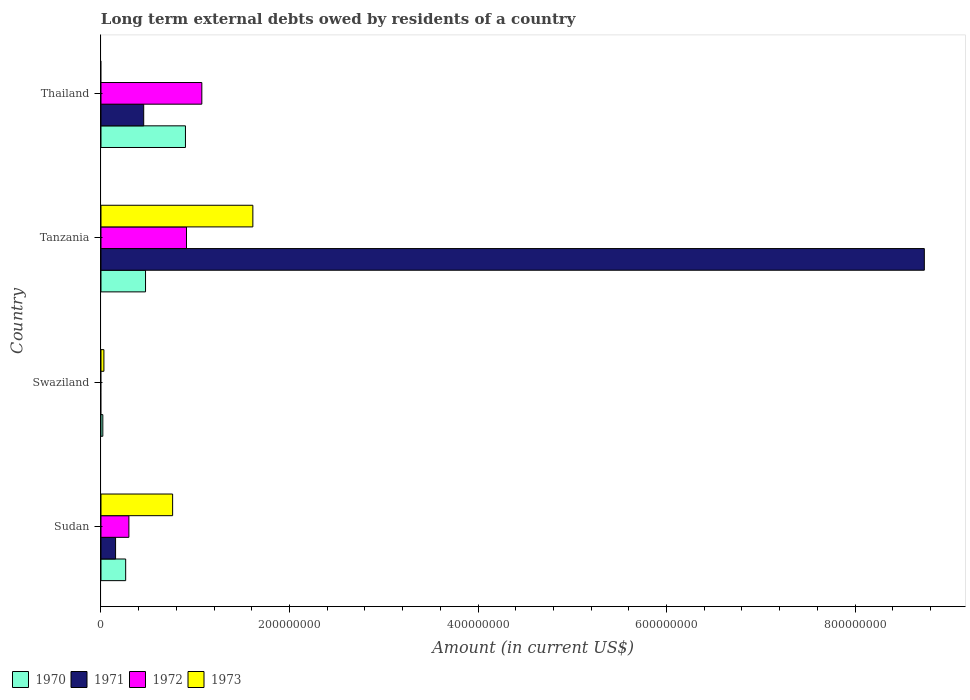How many different coloured bars are there?
Make the answer very short. 4. What is the label of the 4th group of bars from the top?
Offer a terse response. Sudan. What is the amount of long-term external debts owed by residents in 1972 in Tanzania?
Give a very brief answer. 9.07e+07. Across all countries, what is the maximum amount of long-term external debts owed by residents in 1972?
Provide a short and direct response. 1.07e+08. Across all countries, what is the minimum amount of long-term external debts owed by residents in 1970?
Offer a terse response. 1.96e+06. In which country was the amount of long-term external debts owed by residents in 1970 maximum?
Provide a short and direct response. Thailand. What is the total amount of long-term external debts owed by residents in 1973 in the graph?
Offer a terse response. 2.40e+08. What is the difference between the amount of long-term external debts owed by residents in 1970 in Tanzania and that in Thailand?
Make the answer very short. -4.23e+07. What is the difference between the amount of long-term external debts owed by residents in 1970 in Sudan and the amount of long-term external debts owed by residents in 1971 in Thailand?
Your response must be concise. -1.91e+07. What is the average amount of long-term external debts owed by residents in 1973 per country?
Provide a succinct answer. 6.01e+07. What is the difference between the amount of long-term external debts owed by residents in 1970 and amount of long-term external debts owed by residents in 1973 in Swaziland?
Give a very brief answer. -1.13e+06. In how many countries, is the amount of long-term external debts owed by residents in 1971 greater than 80000000 US$?
Give a very brief answer. 1. What is the ratio of the amount of long-term external debts owed by residents in 1972 in Tanzania to that in Thailand?
Your answer should be compact. 0.85. Is the amount of long-term external debts owed by residents in 1971 in Sudan less than that in Thailand?
Your answer should be very brief. Yes. What is the difference between the highest and the second highest amount of long-term external debts owed by residents in 1970?
Keep it short and to the point. 4.23e+07. What is the difference between the highest and the lowest amount of long-term external debts owed by residents in 1972?
Offer a terse response. 1.07e+08. In how many countries, is the amount of long-term external debts owed by residents in 1973 greater than the average amount of long-term external debts owed by residents in 1973 taken over all countries?
Provide a succinct answer. 2. Is it the case that in every country, the sum of the amount of long-term external debts owed by residents in 1970 and amount of long-term external debts owed by residents in 1972 is greater than the sum of amount of long-term external debts owed by residents in 1973 and amount of long-term external debts owed by residents in 1971?
Keep it short and to the point. No. How many bars are there?
Your response must be concise. 13. What is the difference between two consecutive major ticks on the X-axis?
Your answer should be compact. 2.00e+08. Are the values on the major ticks of X-axis written in scientific E-notation?
Your answer should be very brief. No. What is the title of the graph?
Offer a terse response. Long term external debts owed by residents of a country. Does "1977" appear as one of the legend labels in the graph?
Provide a short and direct response. No. What is the Amount (in current US$) in 1970 in Sudan?
Make the answer very short. 2.62e+07. What is the Amount (in current US$) in 1971 in Sudan?
Your response must be concise. 1.55e+07. What is the Amount (in current US$) of 1972 in Sudan?
Offer a terse response. 2.96e+07. What is the Amount (in current US$) in 1973 in Sudan?
Ensure brevity in your answer.  7.60e+07. What is the Amount (in current US$) of 1970 in Swaziland?
Provide a succinct answer. 1.96e+06. What is the Amount (in current US$) of 1971 in Swaziland?
Make the answer very short. 0. What is the Amount (in current US$) of 1973 in Swaziland?
Keep it short and to the point. 3.09e+06. What is the Amount (in current US$) in 1970 in Tanzania?
Offer a terse response. 4.73e+07. What is the Amount (in current US$) of 1971 in Tanzania?
Your response must be concise. 8.73e+08. What is the Amount (in current US$) in 1972 in Tanzania?
Keep it short and to the point. 9.07e+07. What is the Amount (in current US$) in 1973 in Tanzania?
Ensure brevity in your answer.  1.61e+08. What is the Amount (in current US$) in 1970 in Thailand?
Offer a terse response. 8.96e+07. What is the Amount (in current US$) of 1971 in Thailand?
Provide a succinct answer. 4.53e+07. What is the Amount (in current US$) in 1972 in Thailand?
Make the answer very short. 1.07e+08. Across all countries, what is the maximum Amount (in current US$) of 1970?
Your answer should be compact. 8.96e+07. Across all countries, what is the maximum Amount (in current US$) of 1971?
Ensure brevity in your answer.  8.73e+08. Across all countries, what is the maximum Amount (in current US$) of 1972?
Your answer should be very brief. 1.07e+08. Across all countries, what is the maximum Amount (in current US$) of 1973?
Ensure brevity in your answer.  1.61e+08. Across all countries, what is the minimum Amount (in current US$) of 1970?
Give a very brief answer. 1.96e+06. Across all countries, what is the minimum Amount (in current US$) of 1971?
Provide a succinct answer. 0. Across all countries, what is the minimum Amount (in current US$) of 1972?
Ensure brevity in your answer.  0. What is the total Amount (in current US$) in 1970 in the graph?
Provide a short and direct response. 1.65e+08. What is the total Amount (in current US$) in 1971 in the graph?
Offer a very short reply. 9.34e+08. What is the total Amount (in current US$) of 1972 in the graph?
Give a very brief answer. 2.27e+08. What is the total Amount (in current US$) in 1973 in the graph?
Make the answer very short. 2.40e+08. What is the difference between the Amount (in current US$) of 1970 in Sudan and that in Swaziland?
Keep it short and to the point. 2.42e+07. What is the difference between the Amount (in current US$) of 1973 in Sudan and that in Swaziland?
Provide a short and direct response. 7.29e+07. What is the difference between the Amount (in current US$) of 1970 in Sudan and that in Tanzania?
Provide a short and direct response. -2.11e+07. What is the difference between the Amount (in current US$) in 1971 in Sudan and that in Tanzania?
Make the answer very short. -8.58e+08. What is the difference between the Amount (in current US$) in 1972 in Sudan and that in Tanzania?
Your response must be concise. -6.11e+07. What is the difference between the Amount (in current US$) of 1973 in Sudan and that in Tanzania?
Keep it short and to the point. -8.51e+07. What is the difference between the Amount (in current US$) in 1970 in Sudan and that in Thailand?
Ensure brevity in your answer.  -6.34e+07. What is the difference between the Amount (in current US$) of 1971 in Sudan and that in Thailand?
Keep it short and to the point. -2.98e+07. What is the difference between the Amount (in current US$) in 1972 in Sudan and that in Thailand?
Your answer should be compact. -7.74e+07. What is the difference between the Amount (in current US$) in 1970 in Swaziland and that in Tanzania?
Provide a succinct answer. -4.53e+07. What is the difference between the Amount (in current US$) in 1973 in Swaziland and that in Tanzania?
Your answer should be compact. -1.58e+08. What is the difference between the Amount (in current US$) of 1970 in Swaziland and that in Thailand?
Offer a terse response. -8.76e+07. What is the difference between the Amount (in current US$) of 1970 in Tanzania and that in Thailand?
Your answer should be compact. -4.23e+07. What is the difference between the Amount (in current US$) of 1971 in Tanzania and that in Thailand?
Provide a succinct answer. 8.28e+08. What is the difference between the Amount (in current US$) in 1972 in Tanzania and that in Thailand?
Offer a very short reply. -1.63e+07. What is the difference between the Amount (in current US$) in 1970 in Sudan and the Amount (in current US$) in 1973 in Swaziland?
Your answer should be very brief. 2.31e+07. What is the difference between the Amount (in current US$) of 1971 in Sudan and the Amount (in current US$) of 1973 in Swaziland?
Offer a terse response. 1.24e+07. What is the difference between the Amount (in current US$) in 1972 in Sudan and the Amount (in current US$) in 1973 in Swaziland?
Offer a terse response. 2.65e+07. What is the difference between the Amount (in current US$) in 1970 in Sudan and the Amount (in current US$) in 1971 in Tanzania?
Offer a terse response. -8.47e+08. What is the difference between the Amount (in current US$) of 1970 in Sudan and the Amount (in current US$) of 1972 in Tanzania?
Offer a terse response. -6.45e+07. What is the difference between the Amount (in current US$) of 1970 in Sudan and the Amount (in current US$) of 1973 in Tanzania?
Ensure brevity in your answer.  -1.35e+08. What is the difference between the Amount (in current US$) in 1971 in Sudan and the Amount (in current US$) in 1972 in Tanzania?
Give a very brief answer. -7.52e+07. What is the difference between the Amount (in current US$) in 1971 in Sudan and the Amount (in current US$) in 1973 in Tanzania?
Give a very brief answer. -1.46e+08. What is the difference between the Amount (in current US$) of 1972 in Sudan and the Amount (in current US$) of 1973 in Tanzania?
Your response must be concise. -1.32e+08. What is the difference between the Amount (in current US$) in 1970 in Sudan and the Amount (in current US$) in 1971 in Thailand?
Make the answer very short. -1.91e+07. What is the difference between the Amount (in current US$) in 1970 in Sudan and the Amount (in current US$) in 1972 in Thailand?
Your answer should be very brief. -8.08e+07. What is the difference between the Amount (in current US$) in 1971 in Sudan and the Amount (in current US$) in 1972 in Thailand?
Keep it short and to the point. -9.15e+07. What is the difference between the Amount (in current US$) in 1970 in Swaziland and the Amount (in current US$) in 1971 in Tanzania?
Give a very brief answer. -8.72e+08. What is the difference between the Amount (in current US$) in 1970 in Swaziland and the Amount (in current US$) in 1972 in Tanzania?
Your answer should be very brief. -8.88e+07. What is the difference between the Amount (in current US$) of 1970 in Swaziland and the Amount (in current US$) of 1973 in Tanzania?
Offer a very short reply. -1.59e+08. What is the difference between the Amount (in current US$) in 1970 in Swaziland and the Amount (in current US$) in 1971 in Thailand?
Offer a terse response. -4.34e+07. What is the difference between the Amount (in current US$) in 1970 in Swaziland and the Amount (in current US$) in 1972 in Thailand?
Provide a succinct answer. -1.05e+08. What is the difference between the Amount (in current US$) of 1970 in Tanzania and the Amount (in current US$) of 1971 in Thailand?
Your response must be concise. 1.95e+06. What is the difference between the Amount (in current US$) of 1970 in Tanzania and the Amount (in current US$) of 1972 in Thailand?
Keep it short and to the point. -5.97e+07. What is the difference between the Amount (in current US$) in 1971 in Tanzania and the Amount (in current US$) in 1972 in Thailand?
Ensure brevity in your answer.  7.67e+08. What is the average Amount (in current US$) of 1970 per country?
Your answer should be very brief. 4.12e+07. What is the average Amount (in current US$) in 1971 per country?
Your answer should be compact. 2.34e+08. What is the average Amount (in current US$) of 1972 per country?
Keep it short and to the point. 5.68e+07. What is the average Amount (in current US$) in 1973 per country?
Keep it short and to the point. 6.01e+07. What is the difference between the Amount (in current US$) in 1970 and Amount (in current US$) in 1971 in Sudan?
Provide a succinct answer. 1.07e+07. What is the difference between the Amount (in current US$) in 1970 and Amount (in current US$) in 1972 in Sudan?
Ensure brevity in your answer.  -3.41e+06. What is the difference between the Amount (in current US$) in 1970 and Amount (in current US$) in 1973 in Sudan?
Provide a short and direct response. -4.98e+07. What is the difference between the Amount (in current US$) of 1971 and Amount (in current US$) of 1972 in Sudan?
Make the answer very short. -1.41e+07. What is the difference between the Amount (in current US$) in 1971 and Amount (in current US$) in 1973 in Sudan?
Ensure brevity in your answer.  -6.05e+07. What is the difference between the Amount (in current US$) of 1972 and Amount (in current US$) of 1973 in Sudan?
Your response must be concise. -4.64e+07. What is the difference between the Amount (in current US$) of 1970 and Amount (in current US$) of 1973 in Swaziland?
Ensure brevity in your answer.  -1.13e+06. What is the difference between the Amount (in current US$) in 1970 and Amount (in current US$) in 1971 in Tanzania?
Ensure brevity in your answer.  -8.26e+08. What is the difference between the Amount (in current US$) in 1970 and Amount (in current US$) in 1972 in Tanzania?
Your response must be concise. -4.35e+07. What is the difference between the Amount (in current US$) in 1970 and Amount (in current US$) in 1973 in Tanzania?
Your response must be concise. -1.14e+08. What is the difference between the Amount (in current US$) of 1971 and Amount (in current US$) of 1972 in Tanzania?
Offer a very short reply. 7.83e+08. What is the difference between the Amount (in current US$) in 1971 and Amount (in current US$) in 1973 in Tanzania?
Provide a short and direct response. 7.12e+08. What is the difference between the Amount (in current US$) of 1972 and Amount (in current US$) of 1973 in Tanzania?
Make the answer very short. -7.04e+07. What is the difference between the Amount (in current US$) in 1970 and Amount (in current US$) in 1971 in Thailand?
Make the answer very short. 4.43e+07. What is the difference between the Amount (in current US$) of 1970 and Amount (in current US$) of 1972 in Thailand?
Offer a very short reply. -1.74e+07. What is the difference between the Amount (in current US$) in 1971 and Amount (in current US$) in 1972 in Thailand?
Give a very brief answer. -6.17e+07. What is the ratio of the Amount (in current US$) of 1970 in Sudan to that in Swaziland?
Ensure brevity in your answer.  13.4. What is the ratio of the Amount (in current US$) of 1973 in Sudan to that in Swaziland?
Your response must be concise. 24.6. What is the ratio of the Amount (in current US$) in 1970 in Sudan to that in Tanzania?
Give a very brief answer. 0.55. What is the ratio of the Amount (in current US$) of 1971 in Sudan to that in Tanzania?
Offer a terse response. 0.02. What is the ratio of the Amount (in current US$) of 1972 in Sudan to that in Tanzania?
Your answer should be very brief. 0.33. What is the ratio of the Amount (in current US$) of 1973 in Sudan to that in Tanzania?
Ensure brevity in your answer.  0.47. What is the ratio of the Amount (in current US$) of 1970 in Sudan to that in Thailand?
Ensure brevity in your answer.  0.29. What is the ratio of the Amount (in current US$) of 1971 in Sudan to that in Thailand?
Offer a very short reply. 0.34. What is the ratio of the Amount (in current US$) of 1972 in Sudan to that in Thailand?
Keep it short and to the point. 0.28. What is the ratio of the Amount (in current US$) in 1970 in Swaziland to that in Tanzania?
Your answer should be very brief. 0.04. What is the ratio of the Amount (in current US$) of 1973 in Swaziland to that in Tanzania?
Give a very brief answer. 0.02. What is the ratio of the Amount (in current US$) of 1970 in Swaziland to that in Thailand?
Provide a short and direct response. 0.02. What is the ratio of the Amount (in current US$) in 1970 in Tanzania to that in Thailand?
Make the answer very short. 0.53. What is the ratio of the Amount (in current US$) of 1971 in Tanzania to that in Thailand?
Your answer should be compact. 19.28. What is the ratio of the Amount (in current US$) of 1972 in Tanzania to that in Thailand?
Give a very brief answer. 0.85. What is the difference between the highest and the second highest Amount (in current US$) of 1970?
Provide a succinct answer. 4.23e+07. What is the difference between the highest and the second highest Amount (in current US$) of 1971?
Provide a short and direct response. 8.28e+08. What is the difference between the highest and the second highest Amount (in current US$) in 1972?
Offer a very short reply. 1.63e+07. What is the difference between the highest and the second highest Amount (in current US$) of 1973?
Make the answer very short. 8.51e+07. What is the difference between the highest and the lowest Amount (in current US$) of 1970?
Provide a succinct answer. 8.76e+07. What is the difference between the highest and the lowest Amount (in current US$) of 1971?
Ensure brevity in your answer.  8.73e+08. What is the difference between the highest and the lowest Amount (in current US$) of 1972?
Your answer should be very brief. 1.07e+08. What is the difference between the highest and the lowest Amount (in current US$) of 1973?
Offer a terse response. 1.61e+08. 